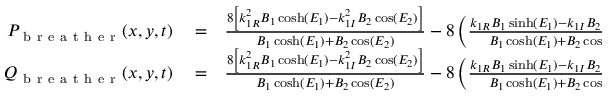Convert formula to latex. <formula><loc_0><loc_0><loc_500><loc_500>\begin{array} { r l r } { P _ { b r e a t h e r } ( x , y , t ) } & = } & { \frac { 8 \left [ k _ { 1 R } ^ { 2 } B _ { 1 } \cosh ( E _ { 1 } ) - k _ { 1 I } ^ { 2 } B _ { 2 } \cos ( E _ { 2 } ) \right ] } { B _ { 1 } \cosh ( E _ { 1 } ) + B _ { 2 } \cos ( E _ { 2 } ) } - 8 \left ( \frac { k _ { 1 R } B _ { 1 } \sinh ( E _ { 1 } ) - k _ { 1 I } B _ { 2 } \sin ( E _ { 2 } ) } { B _ { 1 } \cosh ( E _ { 1 } ) + B _ { 2 } \cos ( E _ { 2 } ) } \right ) ^ { 2 } } \\ { Q _ { b r e a t h e r } ( x , y , t ) } & = } & { \frac { 8 \left [ k _ { 1 R } ^ { 2 } B _ { 1 } \cosh ( E _ { 1 } ) - k _ { 1 I } ^ { 2 } B _ { 2 } \cos ( E _ { 2 } ) \right ] } { B _ { 1 } \cosh ( E _ { 1 } ) + B _ { 2 } \cos ( E _ { 2 } ) } - 8 \left ( \frac { k _ { 1 R } B _ { 1 } \sinh ( E _ { 1 } ) - k _ { 1 I } B _ { 2 } \sin ( E _ { 2 } ) } { B _ { 1 } \cosh ( E _ { 1 } ) + B _ { 2 } \cos ( E _ { 2 } ) } \right ) ^ { 2 } } \end{array}</formula> 